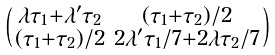<formula> <loc_0><loc_0><loc_500><loc_500>\begin{psmallmatrix} \lambda \tau _ { 1 } + \lambda ^ { \prime } \tau _ { 2 } & ( \tau _ { 1 } + \tau _ { 2 } ) / 2 \\ ( \tau _ { 1 } + \tau _ { 2 } ) / 2 & 2 \lambda ^ { \prime } \tau _ { 1 } / 7 + 2 \lambda \tau _ { 2 } / 7 \end{psmallmatrix}</formula> 